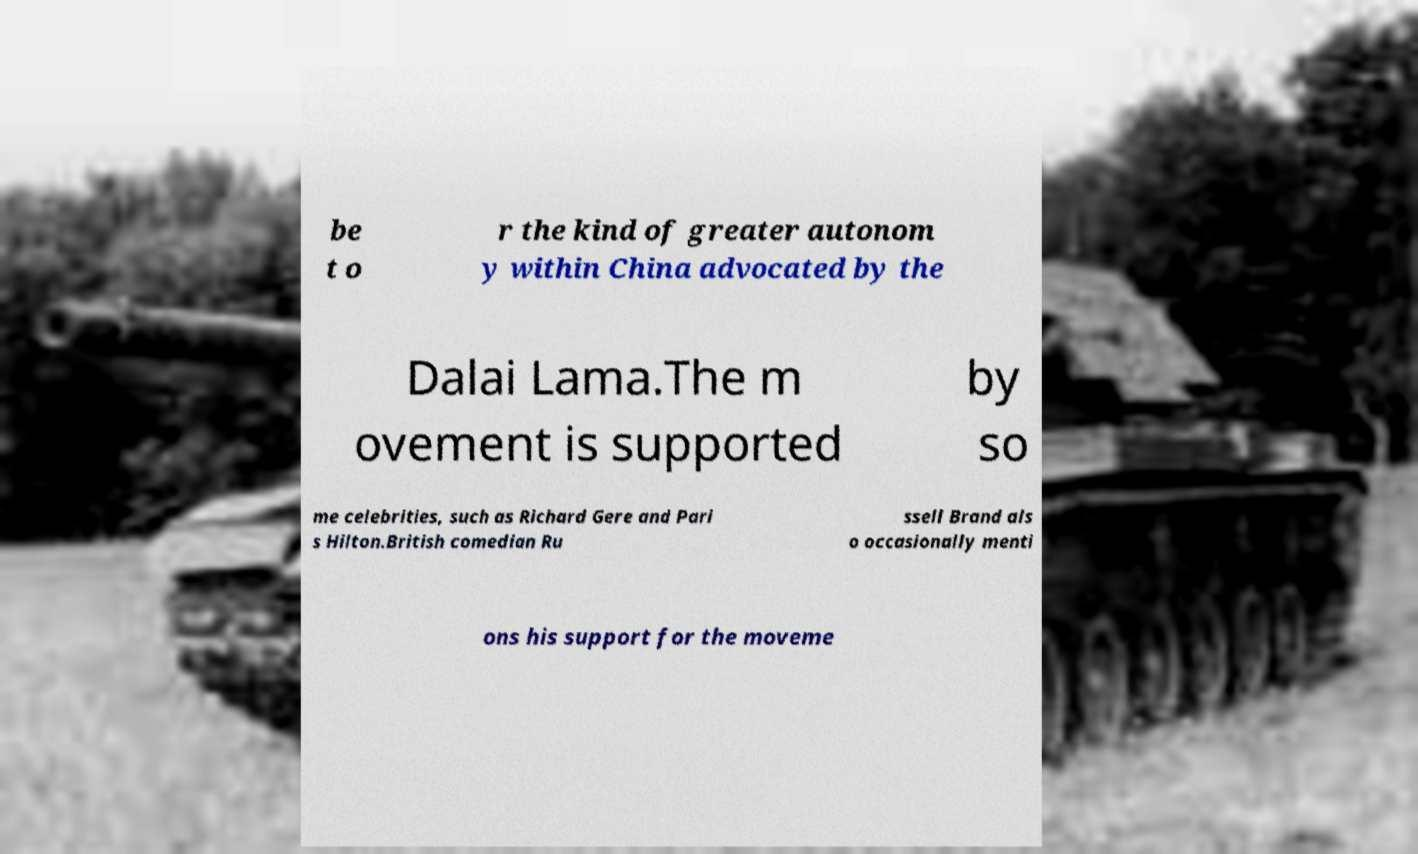There's text embedded in this image that I need extracted. Can you transcribe it verbatim? be t o r the kind of greater autonom y within China advocated by the Dalai Lama.The m ovement is supported by so me celebrities, such as Richard Gere and Pari s Hilton.British comedian Ru ssell Brand als o occasionally menti ons his support for the moveme 